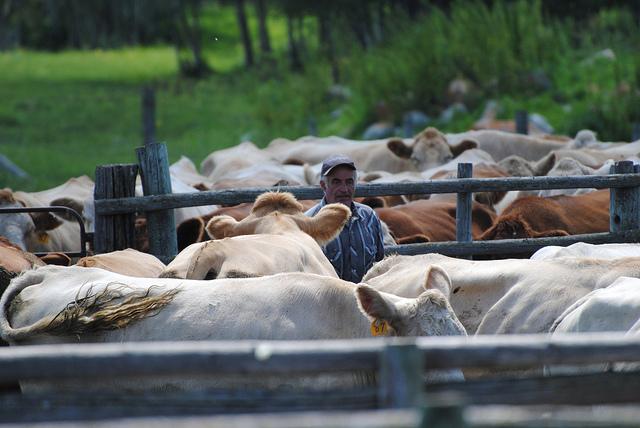What kind of animal is pictured?
Write a very short answer. Cow. Was this taken on a farm?
Answer briefly. Yes. What color is the man's shirt?
Give a very brief answer. Blue. 